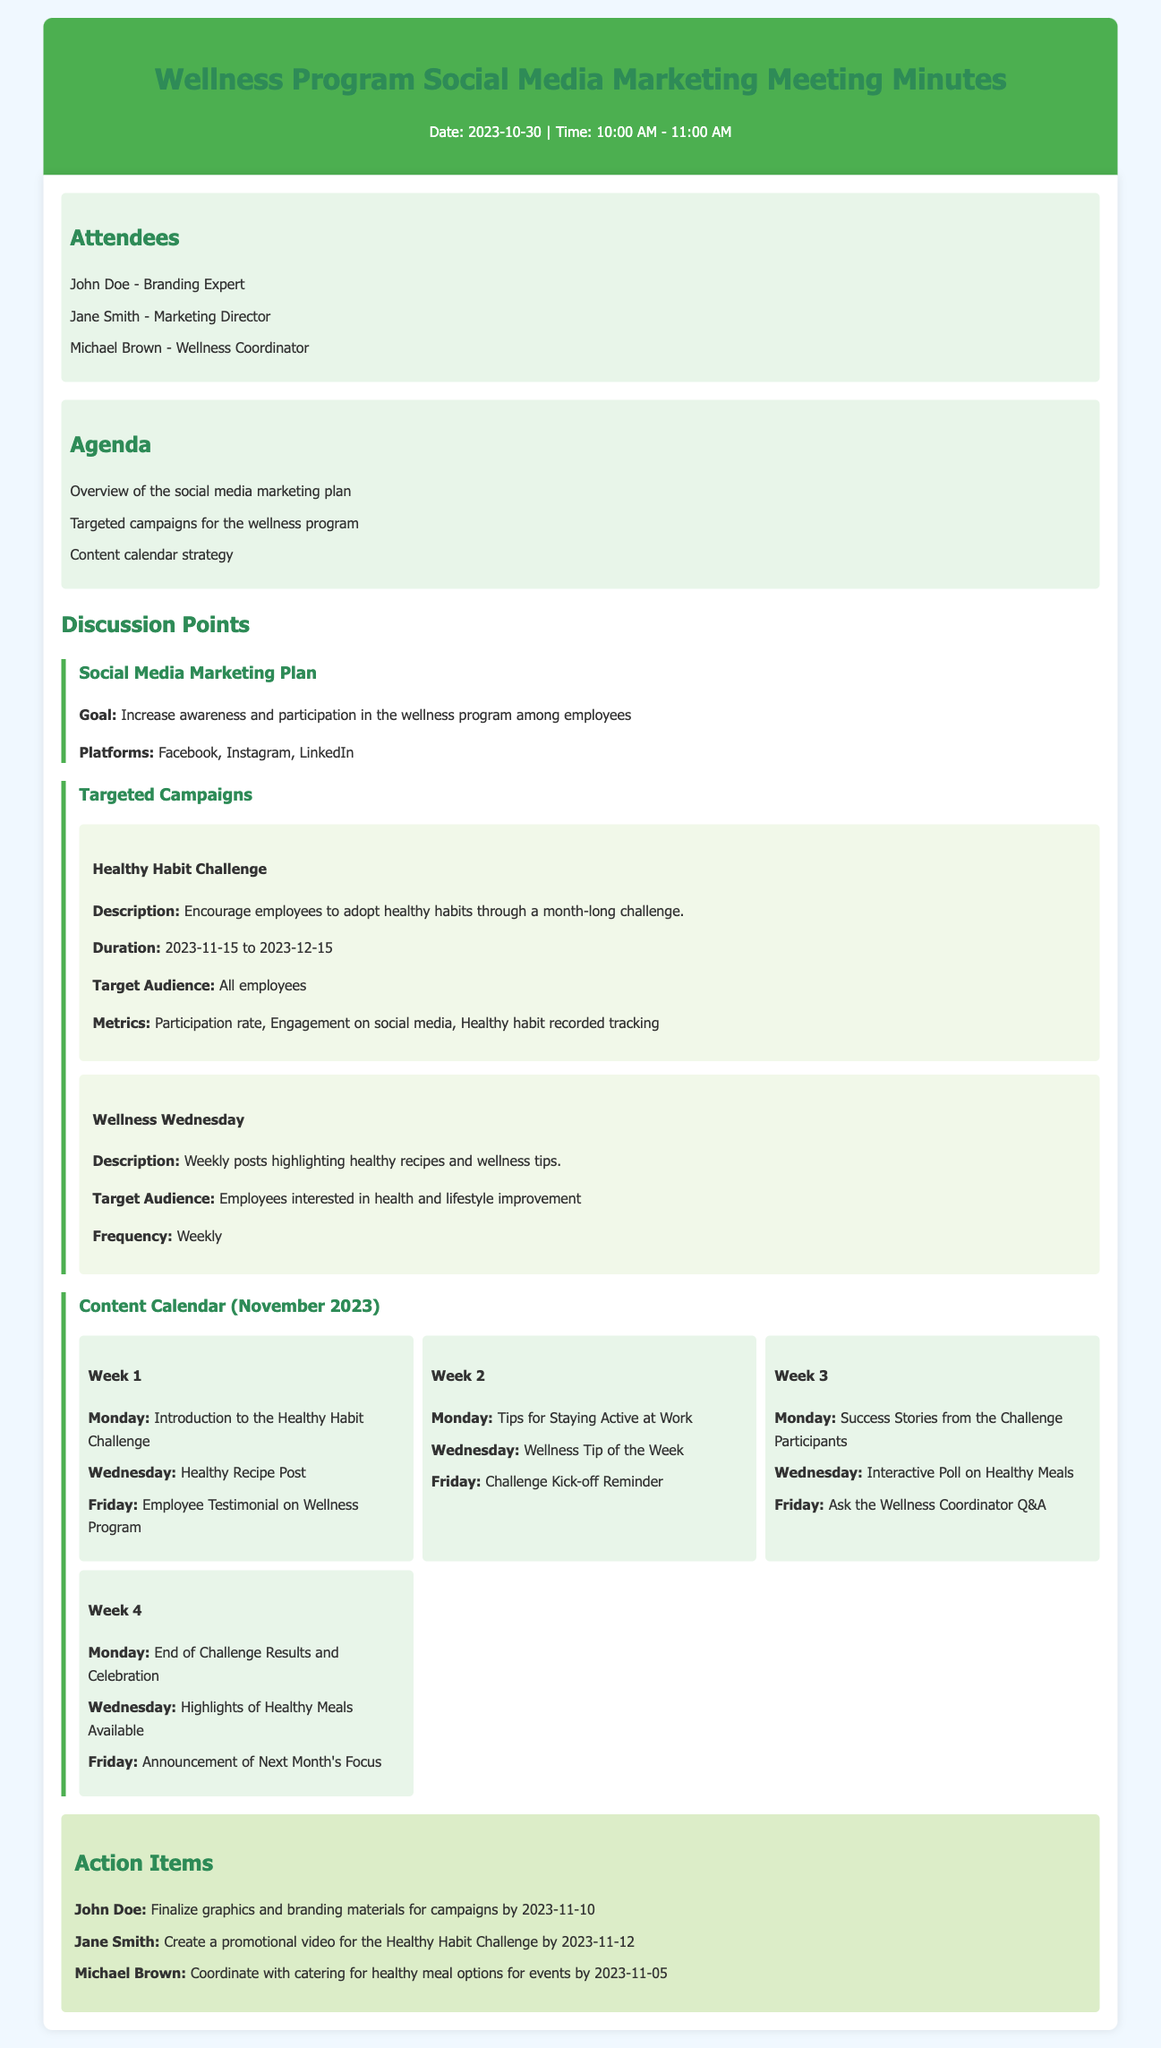What is the date of the meeting? The date of the meeting is explicitly stated at the beginning of the document.
Answer: 2023-10-30 Who is the Marketing Director? The document lists the attendees, including their roles.
Answer: Jane Smith What is the goal of the social media marketing plan? The goal is stated in the section discussing the Social Media Marketing Plan.
Answer: Increase awareness and participation in the wellness program among employees How long will the Healthy Habit Challenge run? The duration of the Healthy Habit Challenge is mentioned in its description.
Answer: 2023-11-15 to 2023-12-15 What platforms will be used for the marketing plan? The platforms are listed in the Social Media Marketing Plan section.
Answer: Facebook, Instagram, LinkedIn How often will the Wellness Wednesday posts occur? The frequency of the Wellness Wednesday posts is specified in the description.
Answer: Weekly What is the focus of the content in Week 1? The document outlines the content planned for Week 1 in the content calendar.
Answer: Introduction to the Healthy Habit Challenge What is one of the action items assigned to John Doe? The action items are listed with assigned individuals and deadlines.
Answer: Finalize graphics and branding materials for campaigns by 2023-11-10 What type of posts are scheduled for the last week of November? The document lists the planned content for each week in the content calendar.
Answer: End of Challenge Results and Celebration 